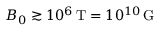<formula> <loc_0><loc_0><loc_500><loc_500>B _ { 0 } \gtrsim 1 0 ^ { 6 } \, T = 1 0 ^ { 1 0 } \, G</formula> 